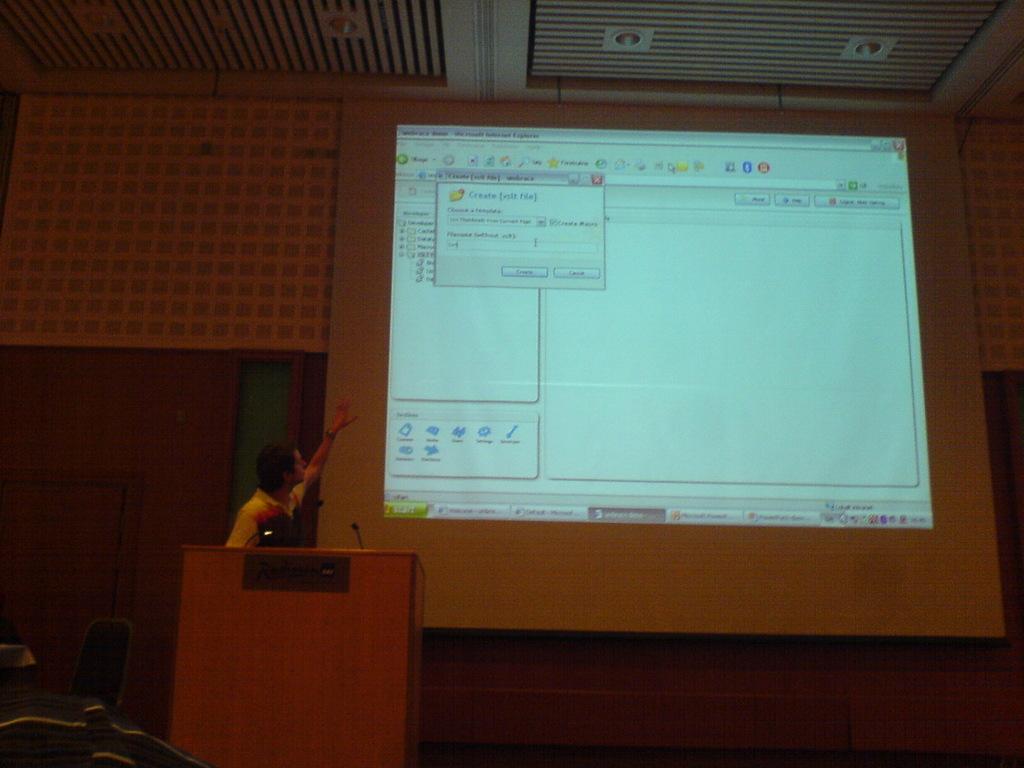Does this slide show you how to create something?
Keep it short and to the point. Yes. What is written on the green button on the bottom corner of the screen?
Your answer should be compact. Start. 